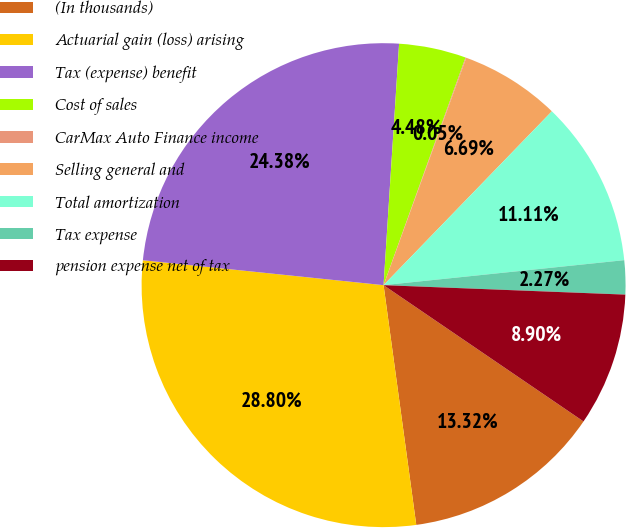<chart> <loc_0><loc_0><loc_500><loc_500><pie_chart><fcel>(In thousands)<fcel>Actuarial gain (loss) arising<fcel>Tax (expense) benefit<fcel>Cost of sales<fcel>CarMax Auto Finance income<fcel>Selling general and<fcel>Total amortization<fcel>Tax expense<fcel>pension expense net of tax<nl><fcel>13.32%<fcel>28.8%<fcel>24.38%<fcel>4.48%<fcel>0.05%<fcel>6.69%<fcel>11.11%<fcel>2.27%<fcel>8.9%<nl></chart> 